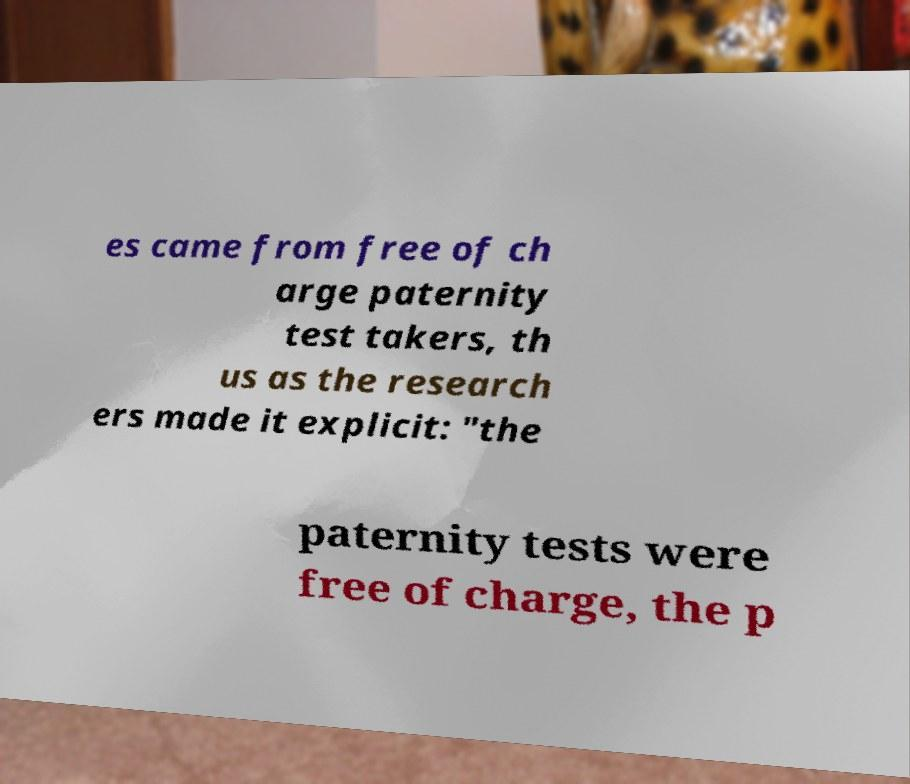I need the written content from this picture converted into text. Can you do that? es came from free of ch arge paternity test takers, th us as the research ers made it explicit: "the paternity tests were free of charge, the p 